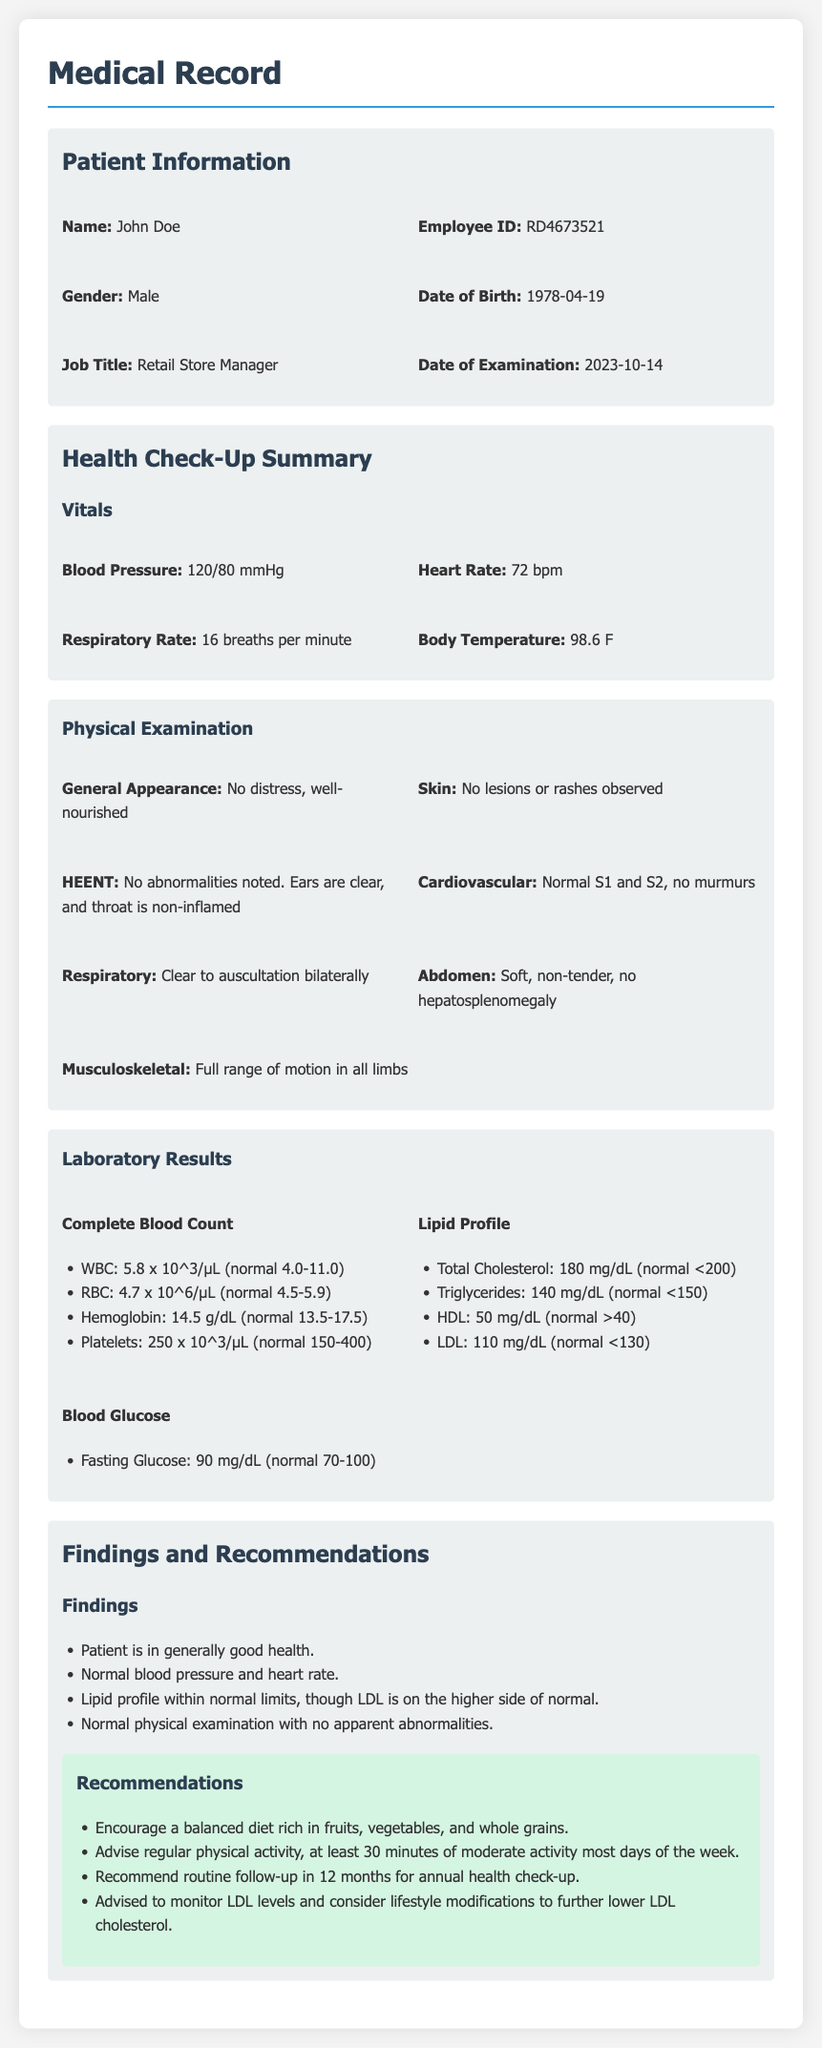What is the name of the patient? The name of the patient is listed under Patient Information in the document.
Answer: John Doe What is the employee ID? The employee ID can be found alongside the patient's name in the Patient Information section.
Answer: RD4673521 What was the date of the examination? The date of the examination is specified in the Patient Information section.
Answer: 2023-10-14 What is the patient's blood pressure reading? The blood pressure reading is detailed under the health check-up summary.
Answer: 120/80 mmHg What is the LDL level mentioned in the lipid profile? The LDL level is listed in the laboratory results section, specifically under the lipid profile.
Answer: 110 mg/dL Was there any distress observed during the physical examination? The observation on general appearance is mentioned in the physical examination section of the document.
Answer: No distress What recommendation is given regarding physical activity? Recommendations for physical activity are outlined in the recommendations section.
Answer: At least 30 minutes of moderate activity most days What finding relates to the patient's general health? The findings about the patient's health are summarized in the findings section of the document.
Answer: Patient is in generally good health What year was the patient born? The year of birth is found in the Patient Information section.
Answer: 1978 